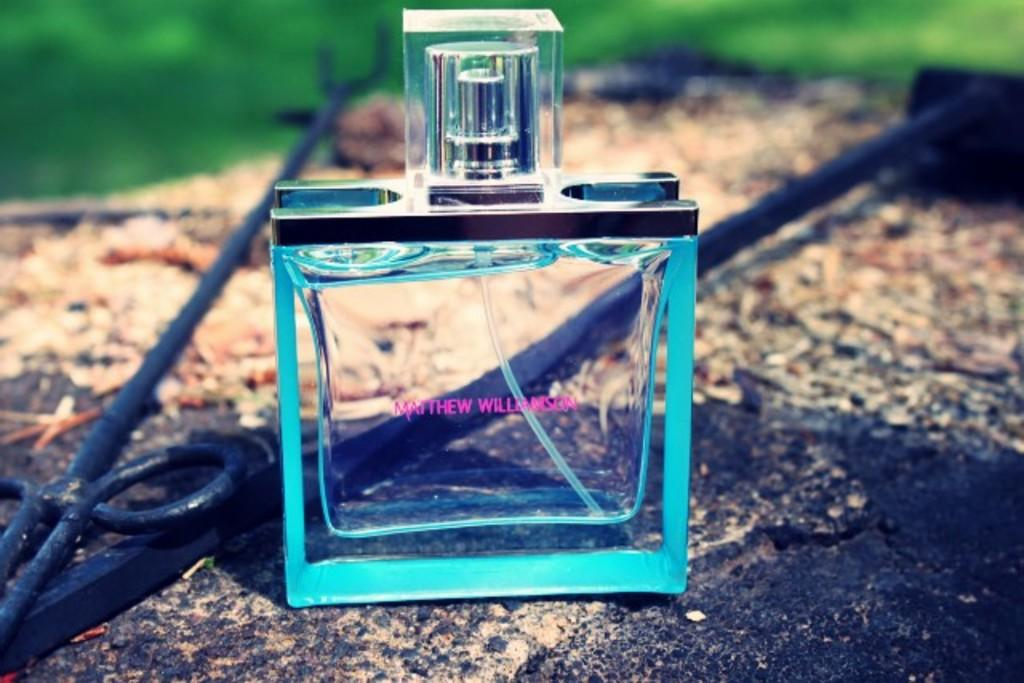<image>
Describe the image concisely. A square bottle has pink letters that spell out Matthew Williamson. 